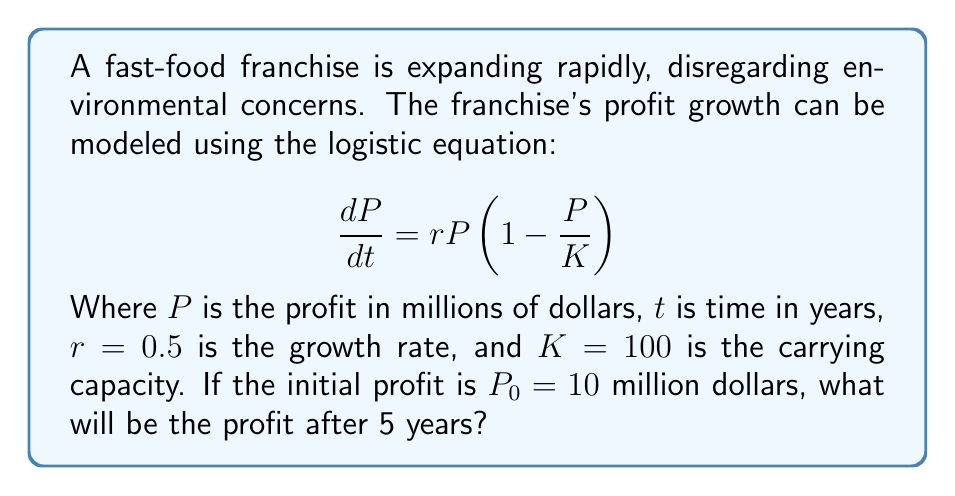Can you solve this math problem? To solve this problem, we need to use the solution to the logistic equation:

$$ P(t) = \frac{KP_0}{P_0 + (K-P_0)e^{-rt}} $$

Step 1: Substitute the given values into the equation:
K = 100, P_0 = 10, r = 0.5, t = 5

$$ P(5) = \frac{100 \cdot 10}{10 + (100-10)e^{-0.5 \cdot 5}} $$

Step 2: Simplify the expression in the denominator:
$$ P(5) = \frac{1000}{10 + 90e^{-2.5}} $$

Step 3: Calculate $e^{-2.5}$:
$e^{-2.5} \approx 0.0821$

Step 4: Substitute this value and calculate:
$$ P(5) = \frac{1000}{10 + 90 \cdot 0.0821} \approx 70.67 $$

Therefore, the profit after 5 years will be approximately 70.67 million dollars.
Answer: $70.67 million 